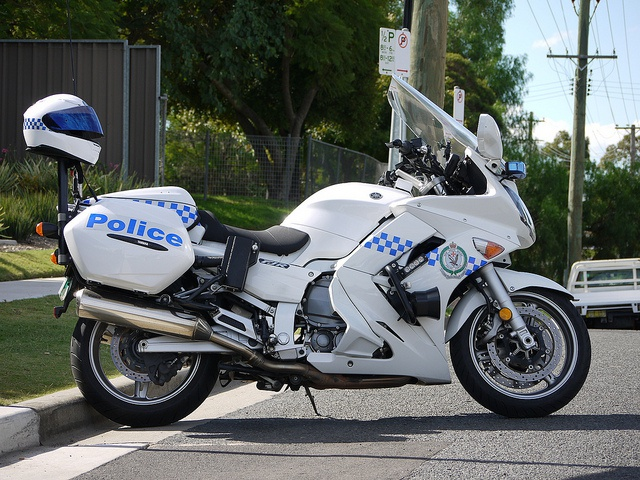Describe the objects in this image and their specific colors. I can see motorcycle in black, darkgray, lightgray, and gray tones and truck in black, darkgray, lightgray, and gray tones in this image. 